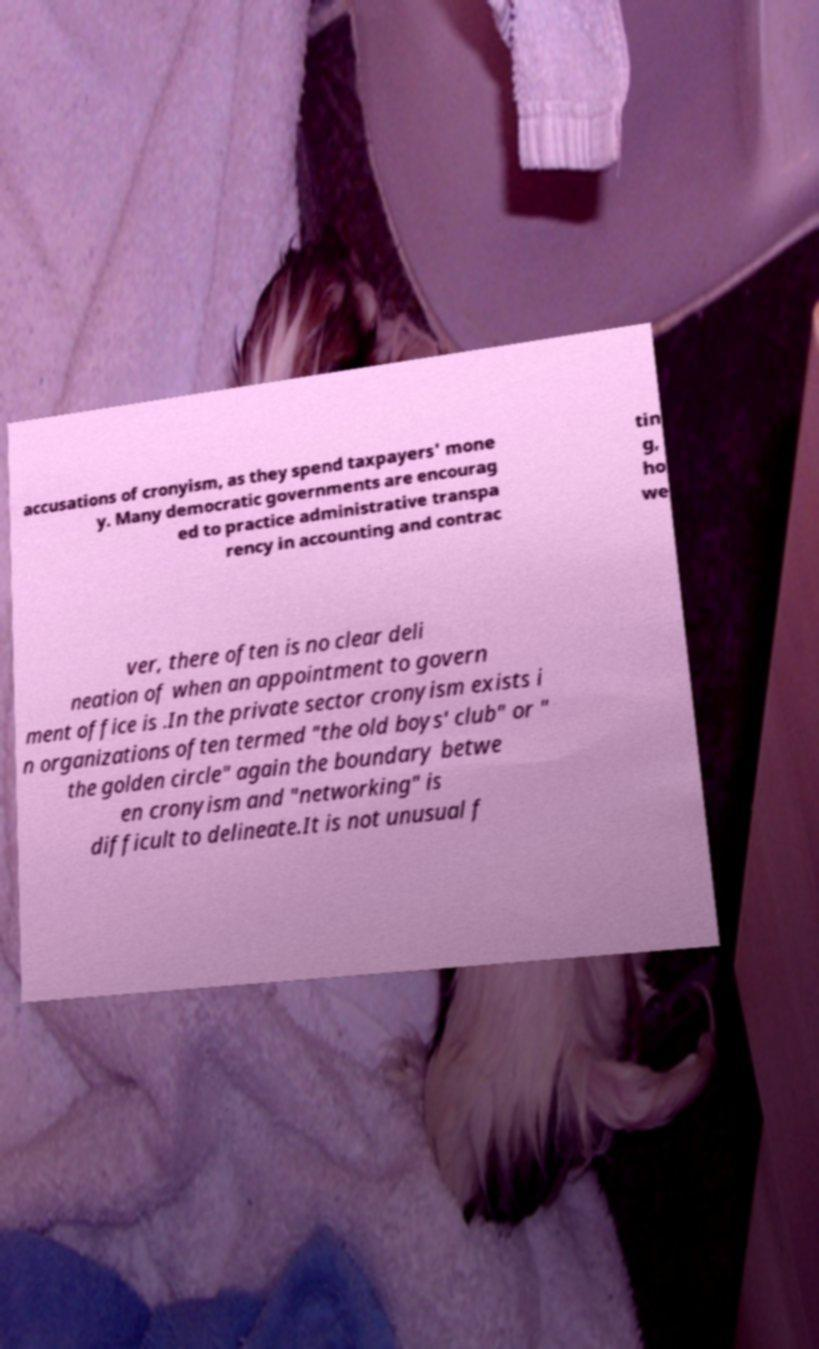There's text embedded in this image that I need extracted. Can you transcribe it verbatim? accusations of cronyism, as they spend taxpayers' mone y. Many democratic governments are encourag ed to practice administrative transpa rency in accounting and contrac tin g, ho we ver, there often is no clear deli neation of when an appointment to govern ment office is .In the private sector cronyism exists i n organizations often termed "the old boys' club" or " the golden circle" again the boundary betwe en cronyism and "networking" is difficult to delineate.It is not unusual f 